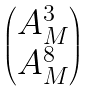Convert formula to latex. <formula><loc_0><loc_0><loc_500><loc_500>\begin{pmatrix} A _ { M } ^ { 3 } \\ A _ { M } ^ { 8 } \end{pmatrix}</formula> 